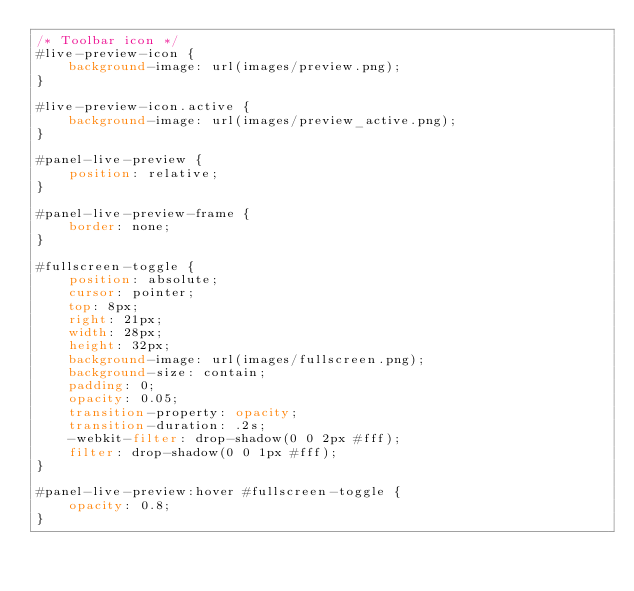Convert code to text. <code><loc_0><loc_0><loc_500><loc_500><_CSS_>/* Toolbar icon */
#live-preview-icon {
    background-image: url(images/preview.png);
}

#live-preview-icon.active {
    background-image: url(images/preview_active.png);
}

#panel-live-preview {
    position: relative;
}

#panel-live-preview-frame {
    border: none;
}

#fullscreen-toggle {
    position: absolute;
    cursor: pointer;
    top: 8px;
    right: 21px;
    width: 28px;
    height: 32px;
    background-image: url(images/fullscreen.png);
    background-size: contain;
    padding: 0;
    opacity: 0.05;
    transition-property: opacity;
    transition-duration: .2s;
    -webkit-filter: drop-shadow(0 0 2px #fff);
    filter: drop-shadow(0 0 1px #fff);
}

#panel-live-preview:hover #fullscreen-toggle {
    opacity: 0.8;
}</code> 